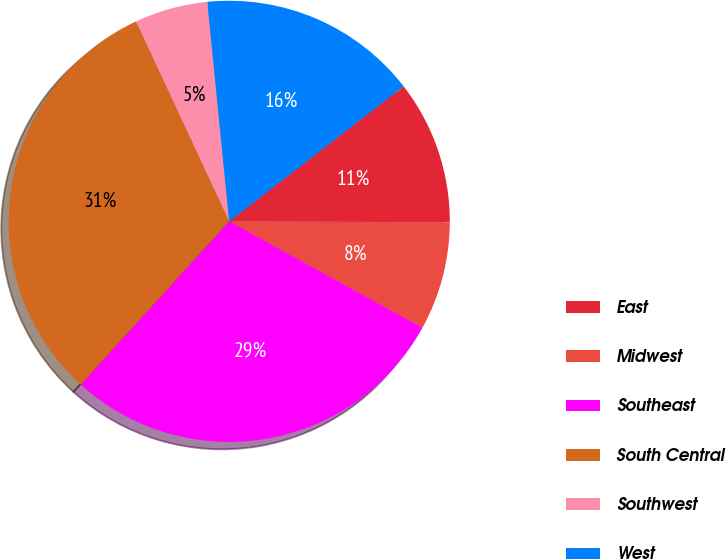Convert chart to OTSL. <chart><loc_0><loc_0><loc_500><loc_500><pie_chart><fcel>East<fcel>Midwest<fcel>Southeast<fcel>South Central<fcel>Southwest<fcel>West<nl><fcel>10.55%<fcel>7.95%<fcel>28.73%<fcel>31.32%<fcel>5.35%<fcel>16.1%<nl></chart> 